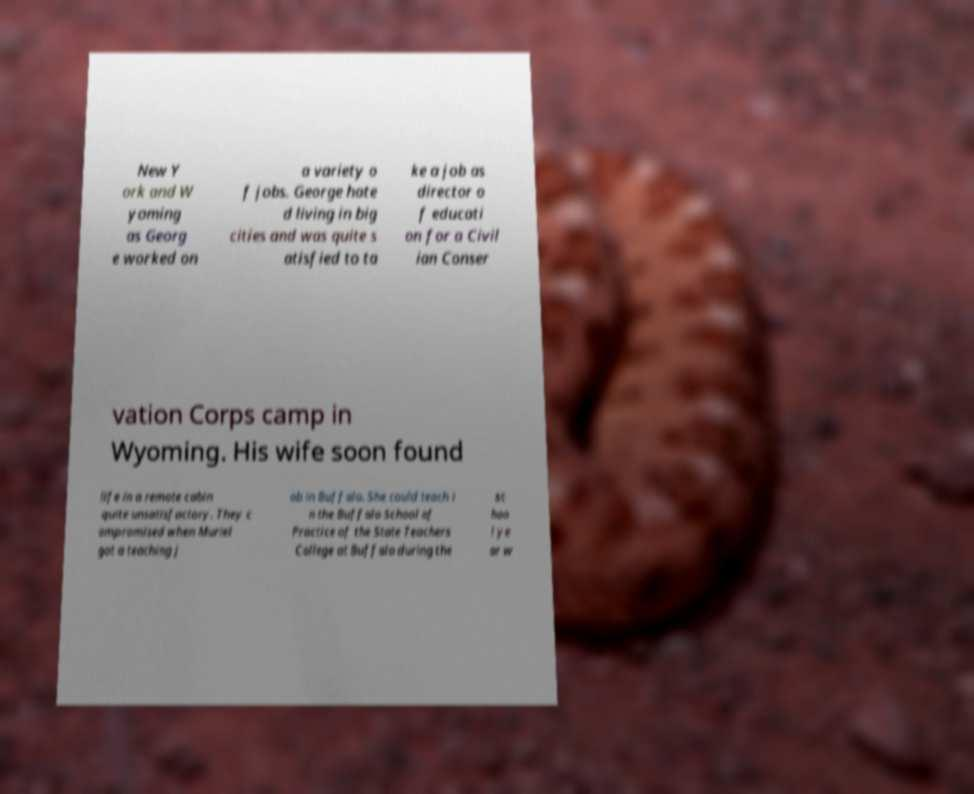Can you read and provide the text displayed in the image?This photo seems to have some interesting text. Can you extract and type it out for me? New Y ork and W yoming as Georg e worked on a variety o f jobs. George hate d living in big cities and was quite s atisfied to ta ke a job as director o f educati on for a Civil ian Conser vation Corps camp in Wyoming. His wife soon found life in a remote cabin quite unsatisfactory. They c ompromised when Muriel got a teaching j ob in Buffalo. She could teach i n the Buffalo School of Practice of the State Teachers College at Buffalo during the sc hoo l ye ar w 